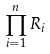<formula> <loc_0><loc_0><loc_500><loc_500>\prod _ { i = 1 } ^ { n } R _ { i }</formula> 